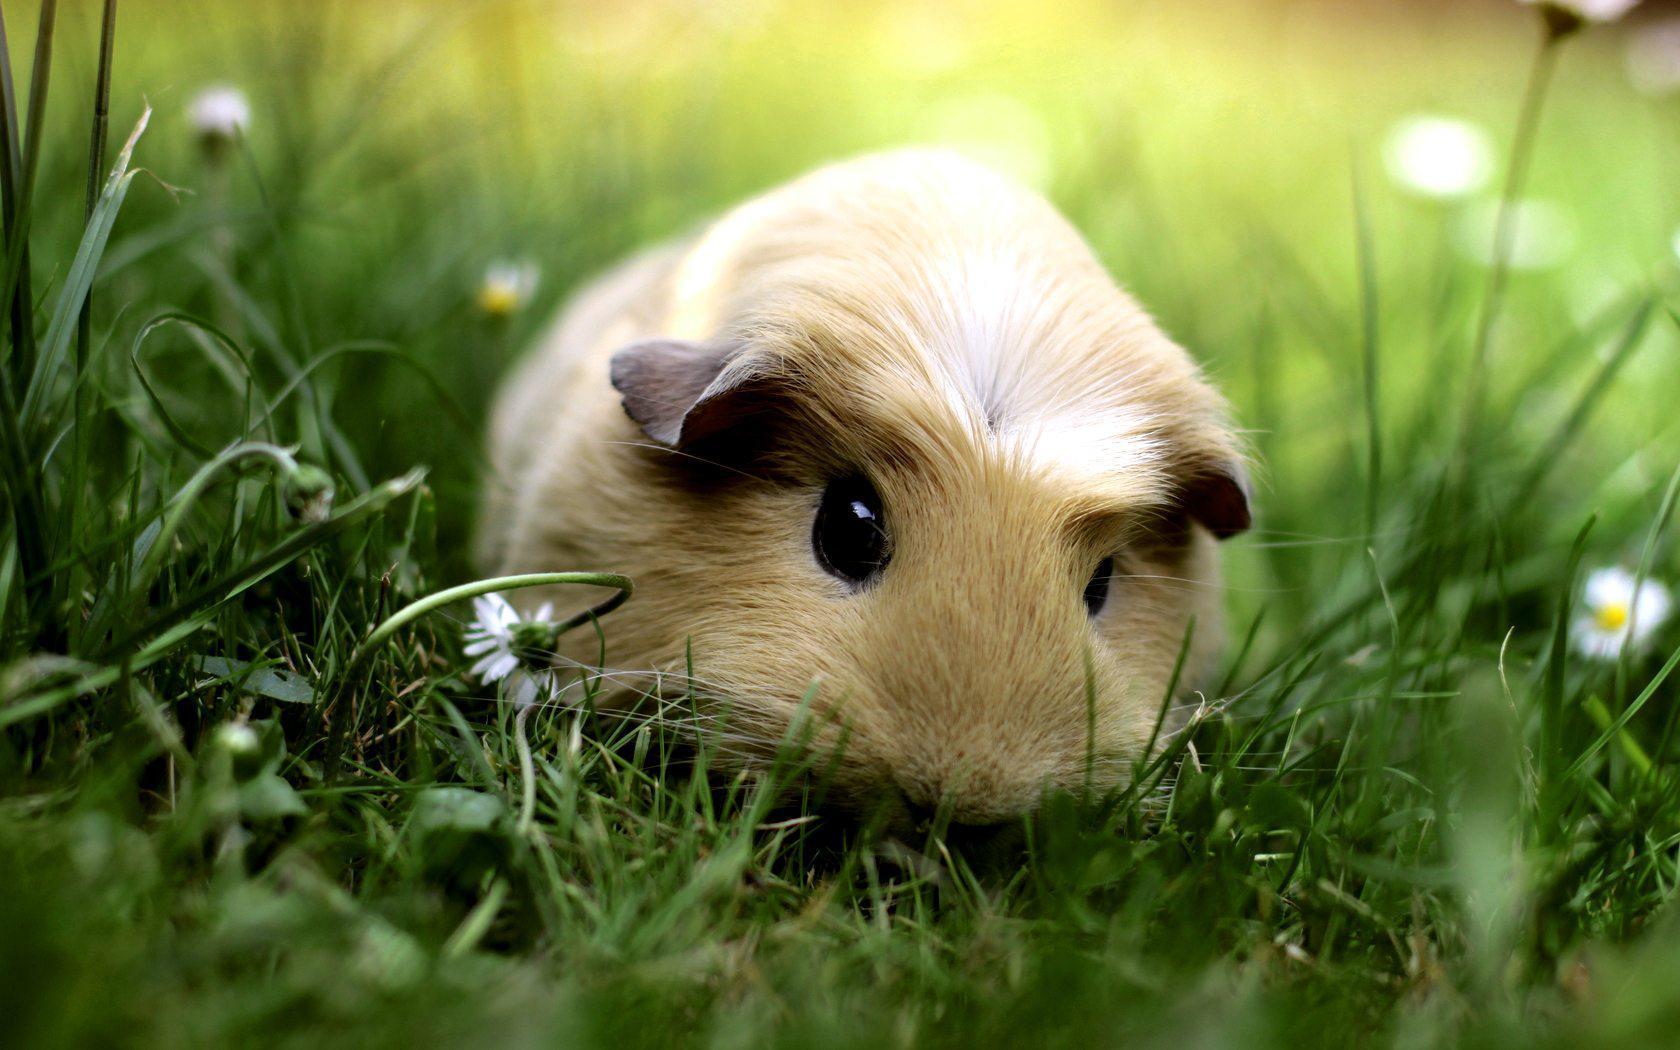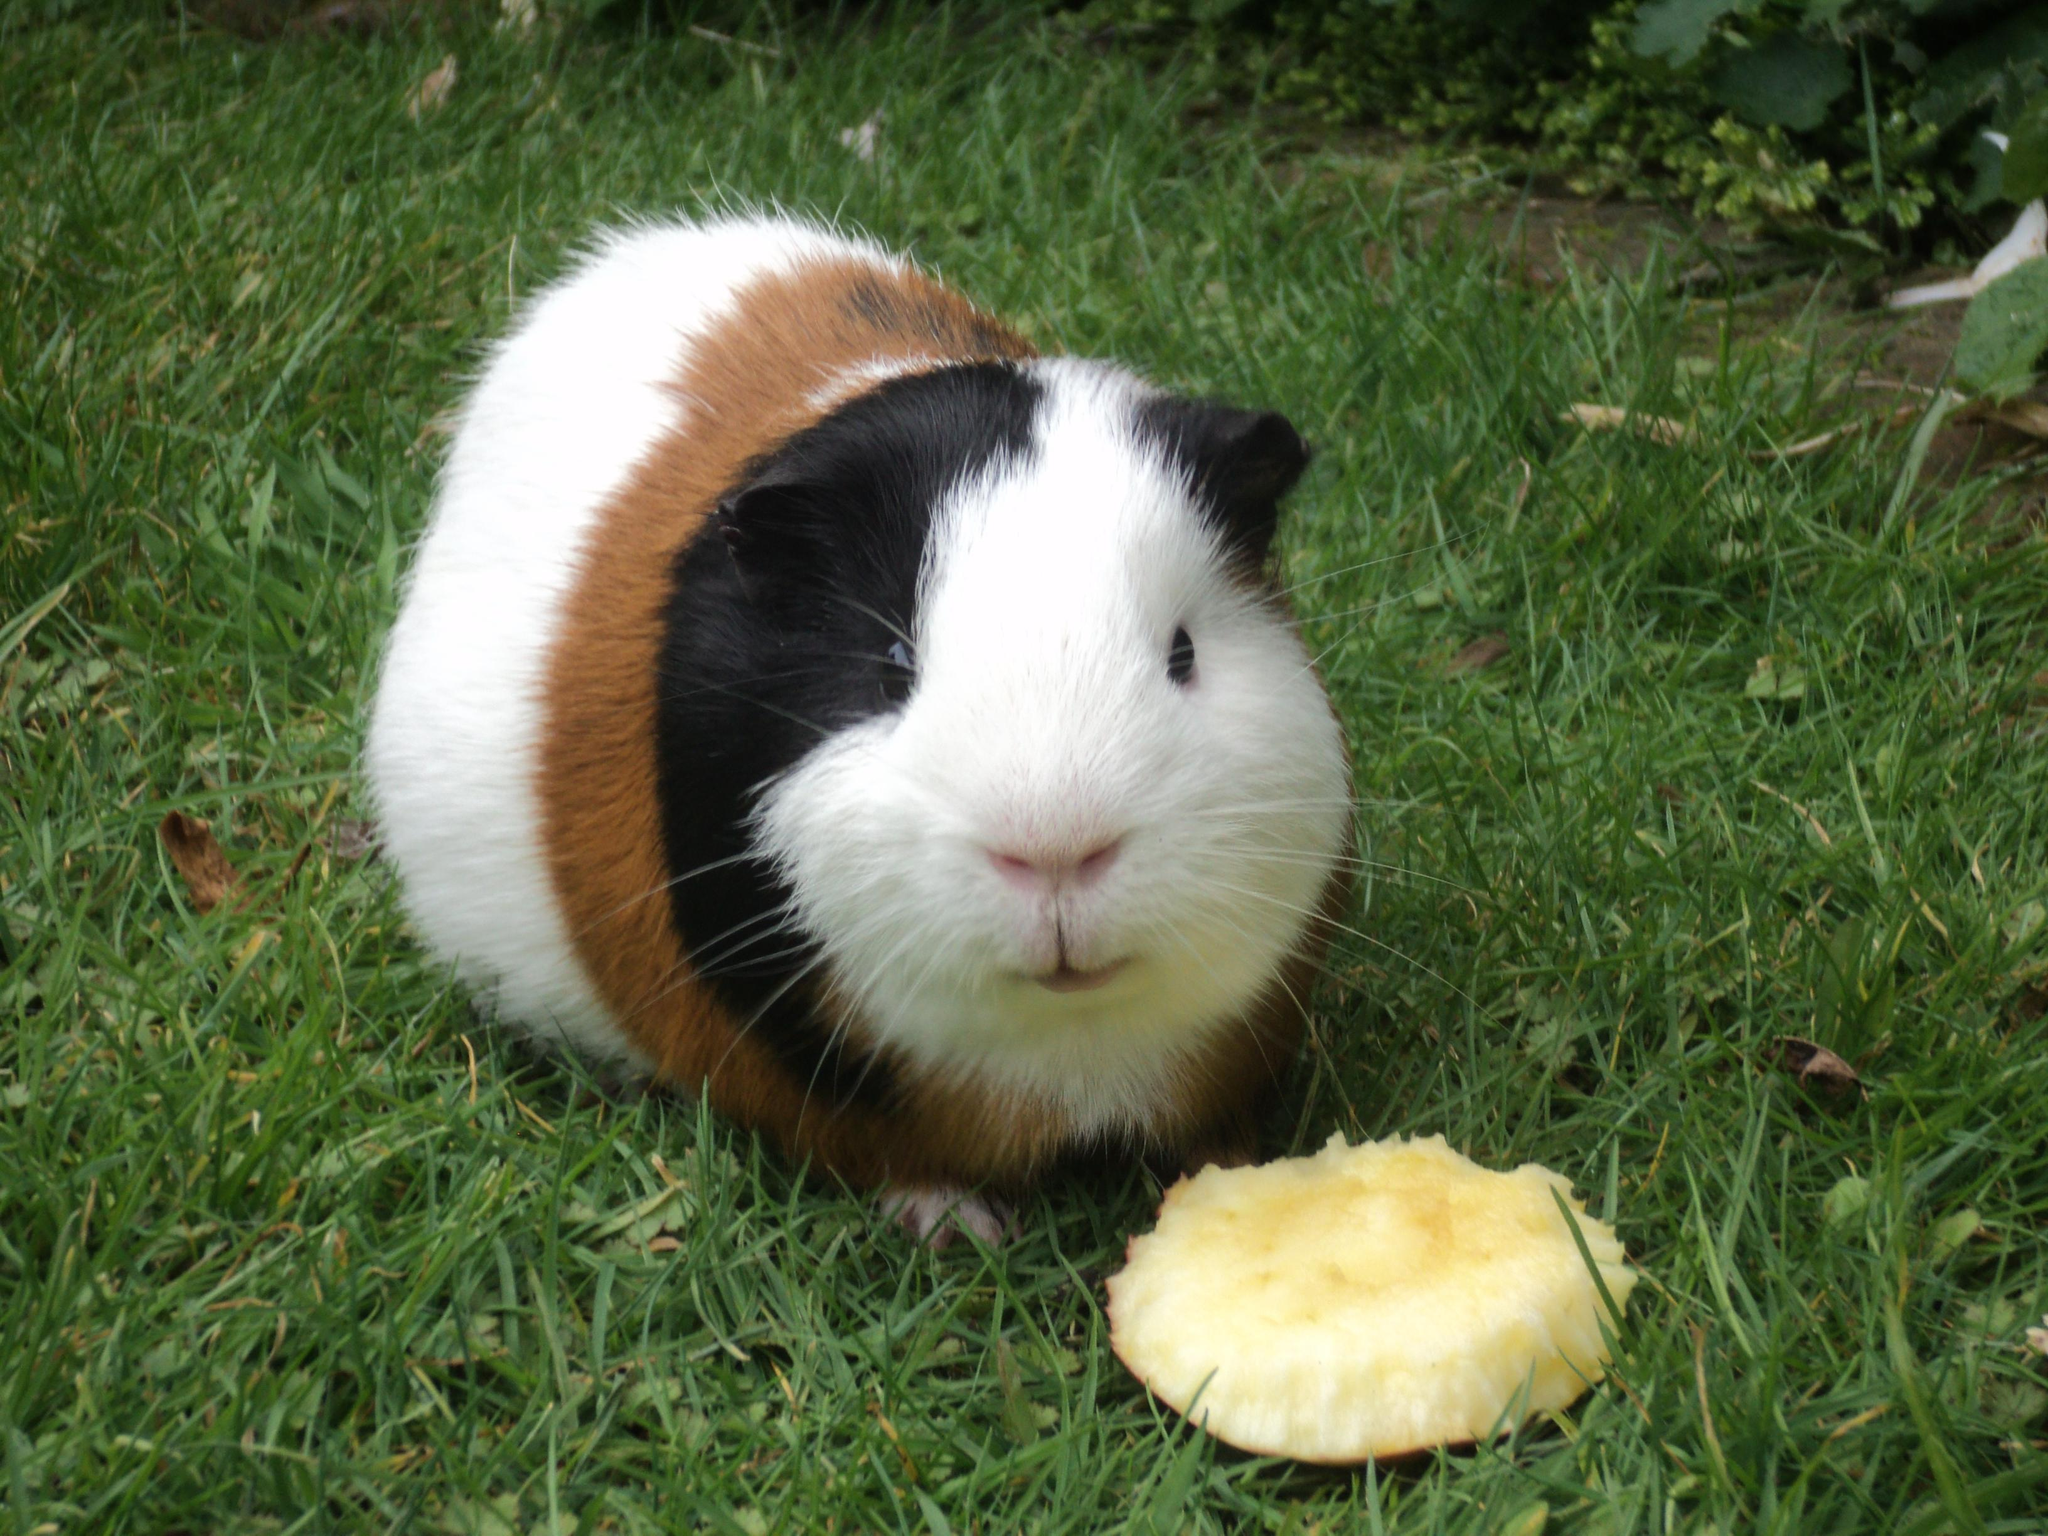The first image is the image on the left, the second image is the image on the right. Considering the images on both sides, is "One of the images shows a guinea pig with daisies on its head." valid? Answer yes or no. No. 